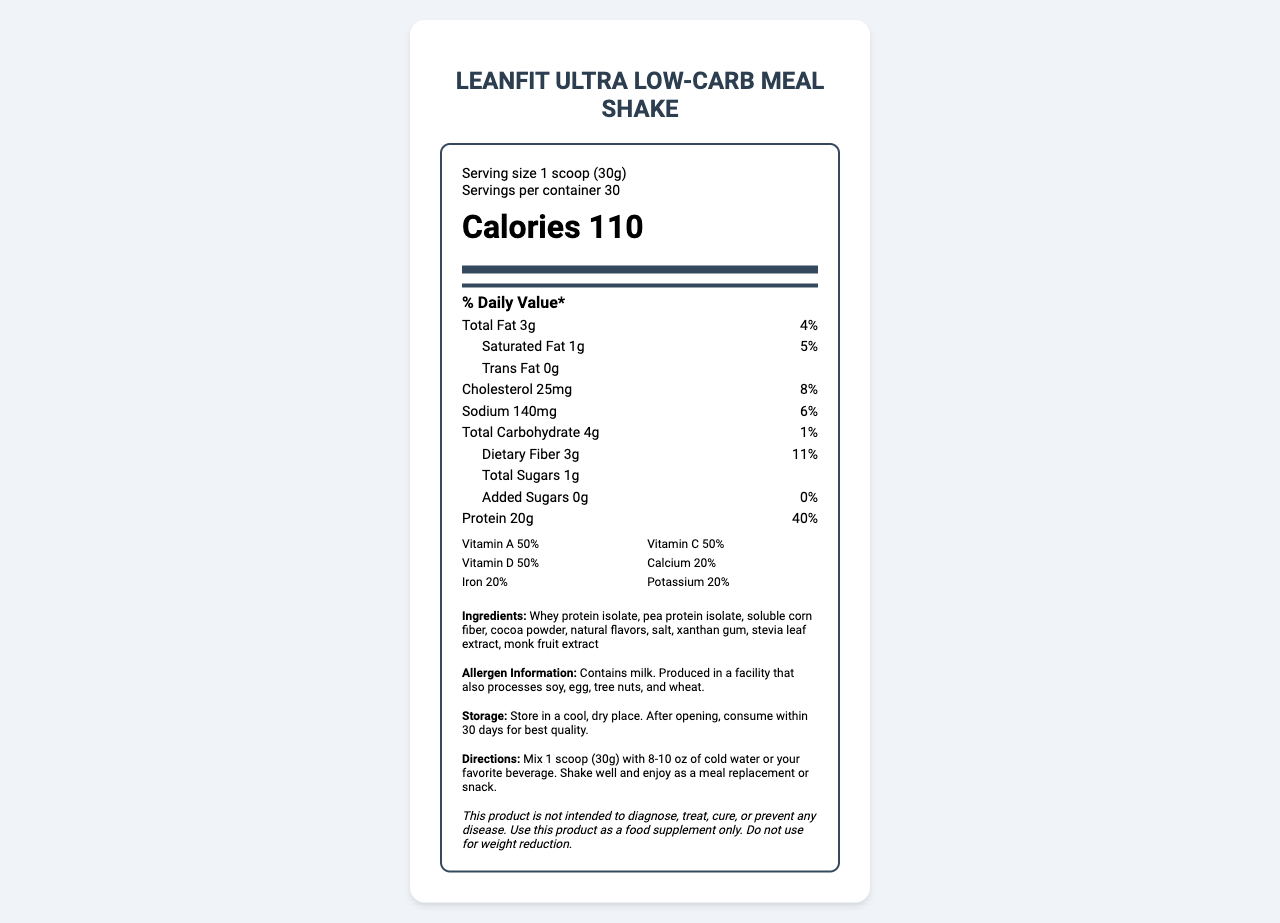what is the serving size? The serving size is clearly mentioned in the serving information at the top of the document.
Answer: 1 scoop (30g) How many calories are in one serving of LeanFit Ultra Low-Carb Meal Shake? The calorie content is prominently displayed within the caloric information section in the document.
Answer: 110 calories What is the total carbohydrate content per serving? The total carbohydrate content per serving is specified in the nutrient section of the document.
Answer: 4g How much dietary fiber does one serving contain? The dietary fiber content is listed under the carbohydrate section in the nutrient details.
Answer: 3g What percentage of the daily value for dietary fiber does one serving provide? The percent daily value for dietary fiber is given alongside the fiber content.
Answer: 11% Which vitamin has the highest daily value percentage in this shake? A. Vitamin C B. Vitamin D C. Vitamin B12 D. Vitamin K The vitamin with the highest daily value percentage is Vitamin C at 50%, which is the highest when compared to other vitamins listed.
Answer: A. Vitamin C How many grams of saturated fat is in a serving? A. 0g B. 0.5g C. 1g D. 2g The document lists 1g of saturated fat per serving in the fat content section.
Answer: C. 1g Does this product contain any trans fat? The trans fat content is listed as 0g in the nutrient information.
Answer: No Is this product gluten-free? The document does not provide information about the presence of gluten or gluten-containing ingredients.
Answer: Cannot be determined Summarize the main nutritional benefits of LeanFit Ultra Low-Carb Meal Shake. The document highlights the product's low-carb profile, high protein content, and significant inclusion of various vitamins and minerals, which collectively cater to a balanced nutritional intake especially suited for weight management.
Answer: The LeanFit Ultra Low-Carb Meal Shake is designed as a meal replacement with a focus on weight management, containing 110 calories per serving. It is low in carbohydrates (4g) and high in protein (20g) along with significant daily values of several essential vitamins and minerals such as Vitamins A, C, D, E, K, and B-complex, making it a balanced and nutrient-dense option. What are the allergens present in this product? The allergen information is clearly stated towards the end of the document, indicating the presence of milk and possible cross-contamination with other allergens.
Answer: Contains milk. Produced in a facility that also processes soy, egg, tree nuts, and wheat. How should this product be stored for best quality after opening? The storage instructions are specific about keeping the product in a cool, dry place and consuming it within 30 days after opening for maintaining best quality.
Answer: Store in a cool, dry place. After opening, consume within 30 days for best quality. 